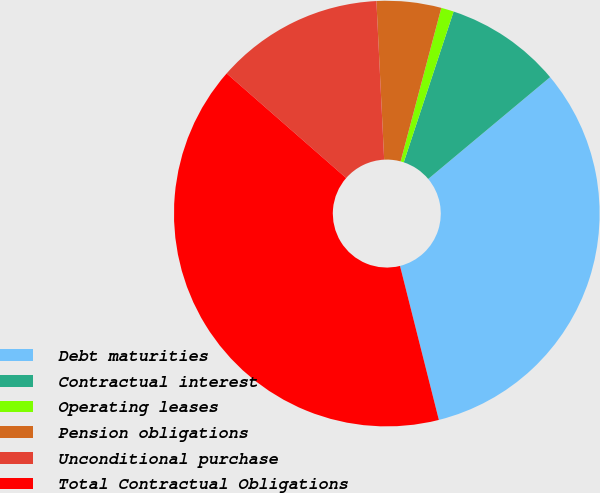<chart> <loc_0><loc_0><loc_500><loc_500><pie_chart><fcel>Debt maturities<fcel>Contractual interest<fcel>Operating leases<fcel>Pension obligations<fcel>Unconditional purchase<fcel>Total Contractual Obligations<nl><fcel>32.14%<fcel>8.84%<fcel>0.96%<fcel>4.9%<fcel>12.78%<fcel>40.37%<nl></chart> 